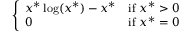<formula> <loc_0><loc_0><loc_500><loc_500>\left \{ \begin{array} { l l } { x ^ { * } \log ( x ^ { * } ) - x ^ { * } } & { { i f } x ^ { * } > 0 } \\ { 0 } & { { i f } x ^ { * } = 0 } \end{array}</formula> 